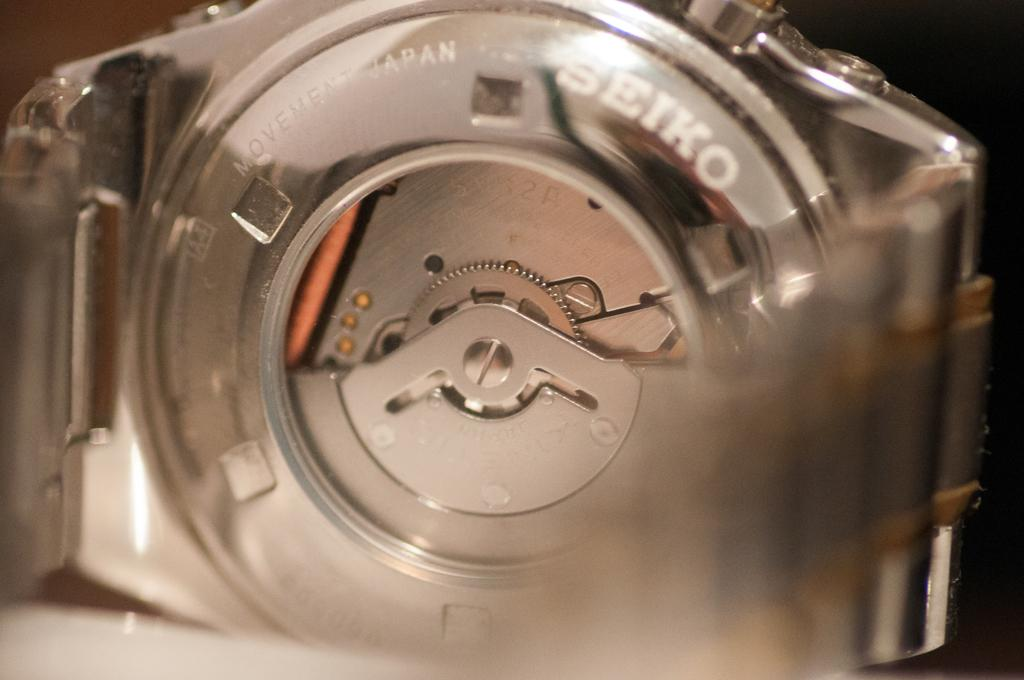<image>
Create a compact narrative representing the image presented. A close up view of the back of a Seiko watch. 